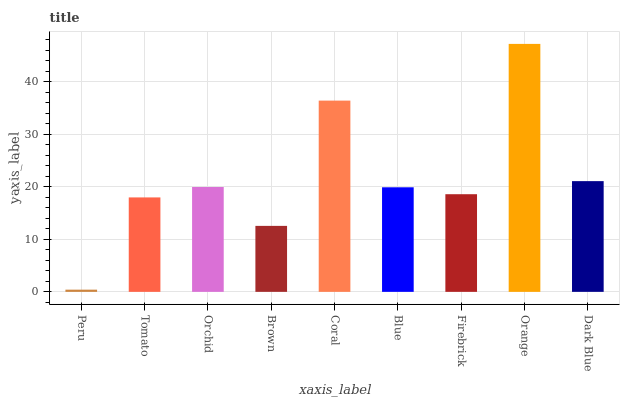Is Peru the minimum?
Answer yes or no. Yes. Is Orange the maximum?
Answer yes or no. Yes. Is Tomato the minimum?
Answer yes or no. No. Is Tomato the maximum?
Answer yes or no. No. Is Tomato greater than Peru?
Answer yes or no. Yes. Is Peru less than Tomato?
Answer yes or no. Yes. Is Peru greater than Tomato?
Answer yes or no. No. Is Tomato less than Peru?
Answer yes or no. No. Is Blue the high median?
Answer yes or no. Yes. Is Blue the low median?
Answer yes or no. Yes. Is Orange the high median?
Answer yes or no. No. Is Tomato the low median?
Answer yes or no. No. 